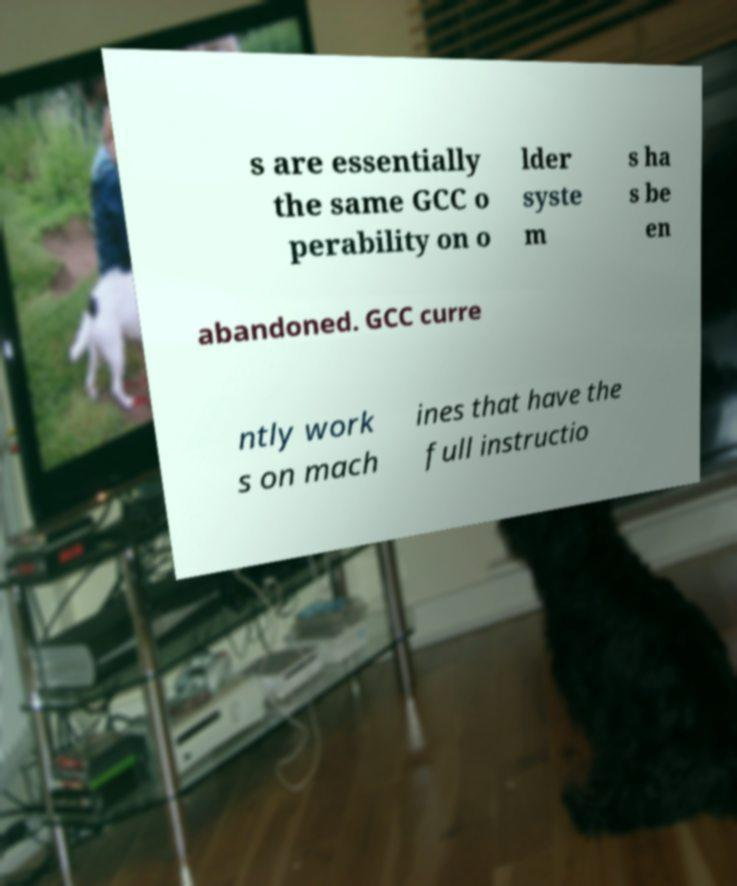There's text embedded in this image that I need extracted. Can you transcribe it verbatim? s are essentially the same GCC o perability on o lder syste m s ha s be en abandoned. GCC curre ntly work s on mach ines that have the full instructio 